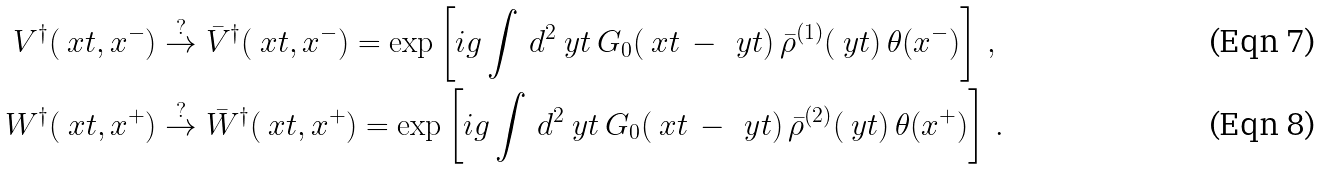Convert formula to latex. <formula><loc_0><loc_0><loc_500><loc_500>V ^ { \dagger } ( \ x t , x ^ { - } ) & \overset { ? } { \to } \bar { V } ^ { \dagger } ( \ x t , x ^ { - } ) = \exp \left [ i g \int \, d ^ { 2 } \ y t \, G _ { 0 } ( \ x t \, - \, \ y t ) \, \bar { \rho } ^ { ( 1 ) } ( \ y t ) \, \theta ( x ^ { - } ) \right ] \, , \\ W ^ { \dagger } ( \ x t , x ^ { + } ) & \overset { ? } { \to } \bar { W } ^ { \dagger } ( \ x t , x ^ { + } ) = \exp \left [ i g \int \, d ^ { 2 } \ y t \, G _ { 0 } ( \ x t \, - \, \ y t ) \, \bar { \rho } ^ { ( 2 ) } ( \ y t ) \, \theta ( x ^ { + } ) \right ] \, .</formula> 